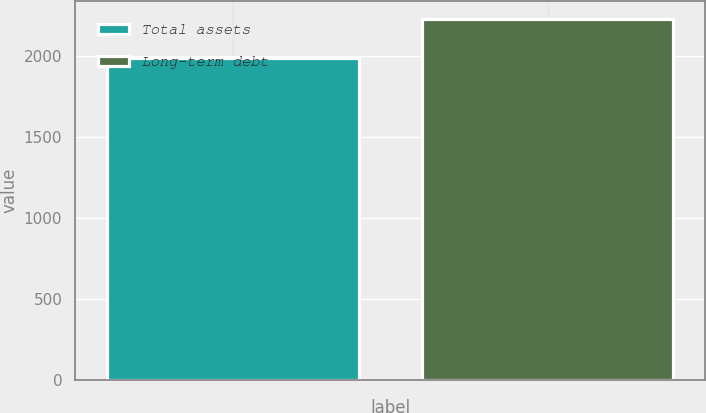Convert chart to OTSL. <chart><loc_0><loc_0><loc_500><loc_500><bar_chart><fcel>Total assets<fcel>Long-term debt<nl><fcel>1990<fcel>2230<nl></chart> 